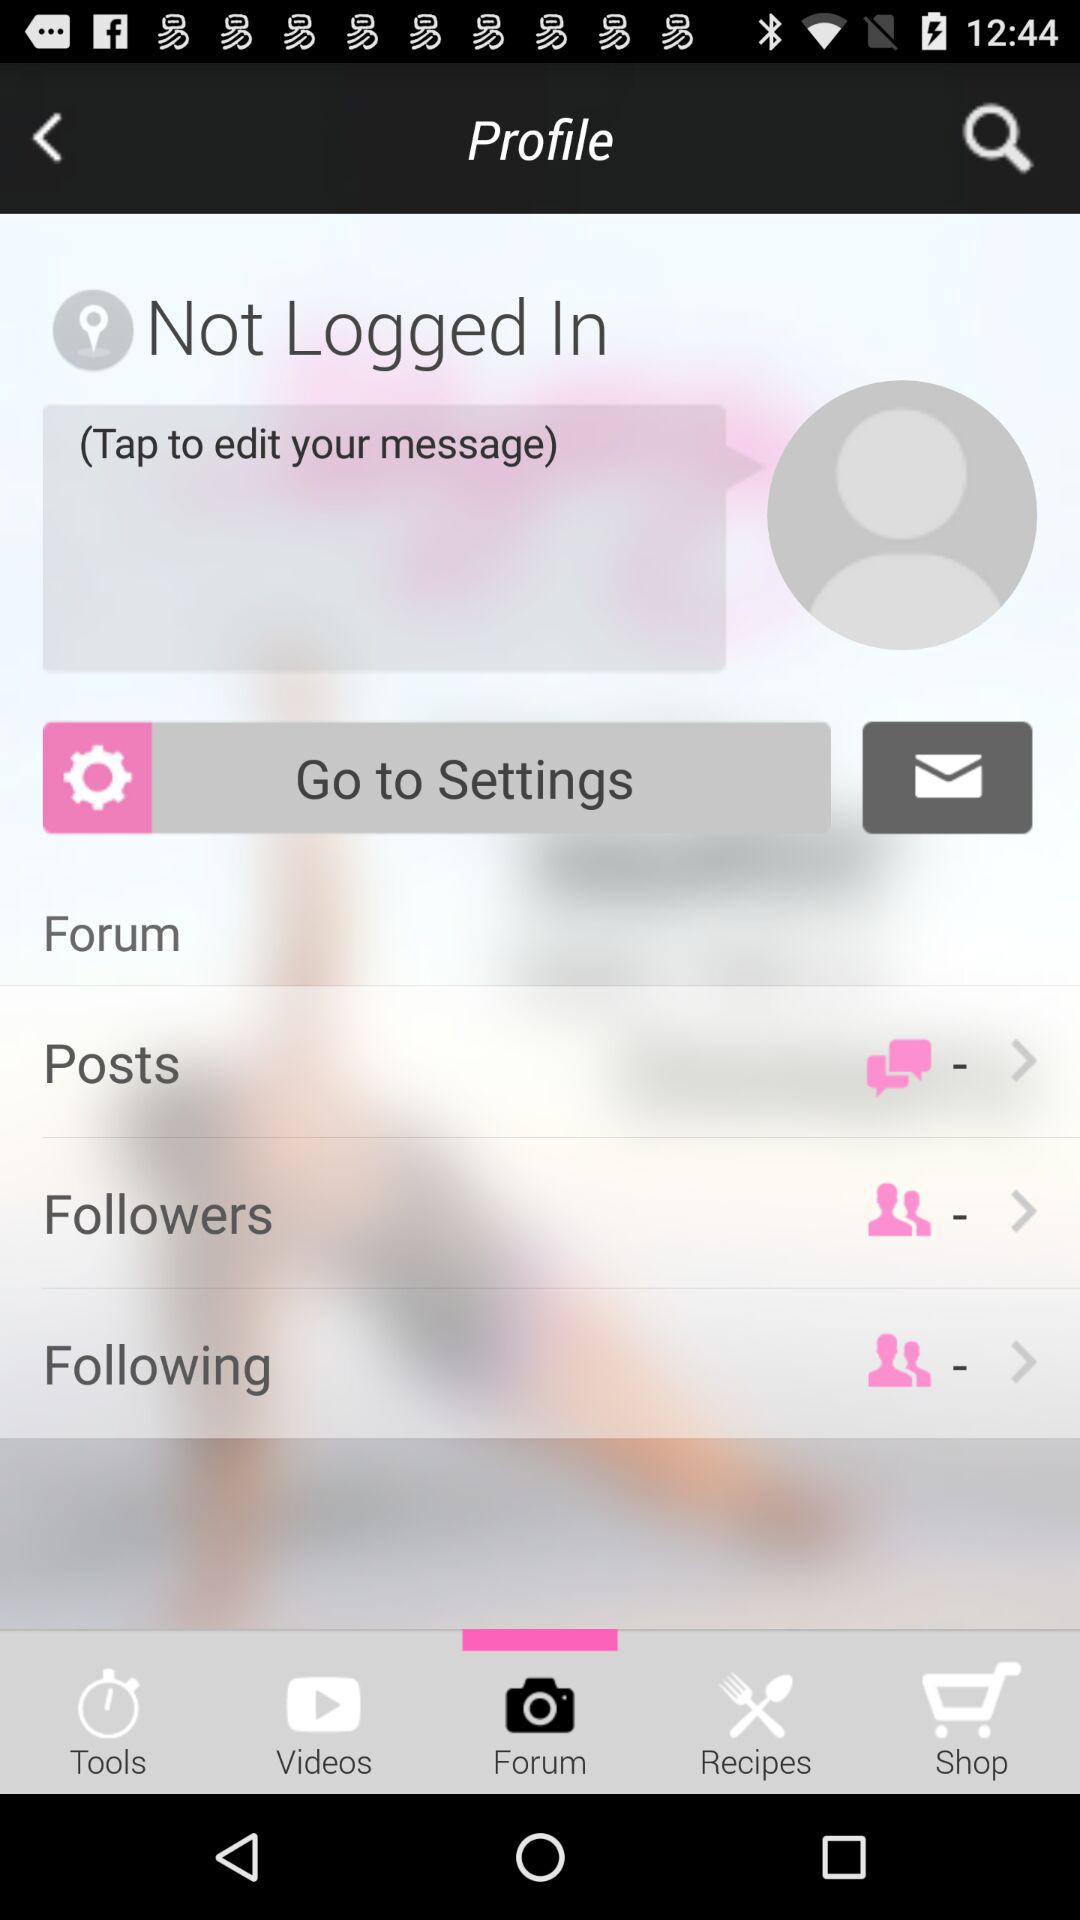Which tab is selected? The selected tab is "Forum". 